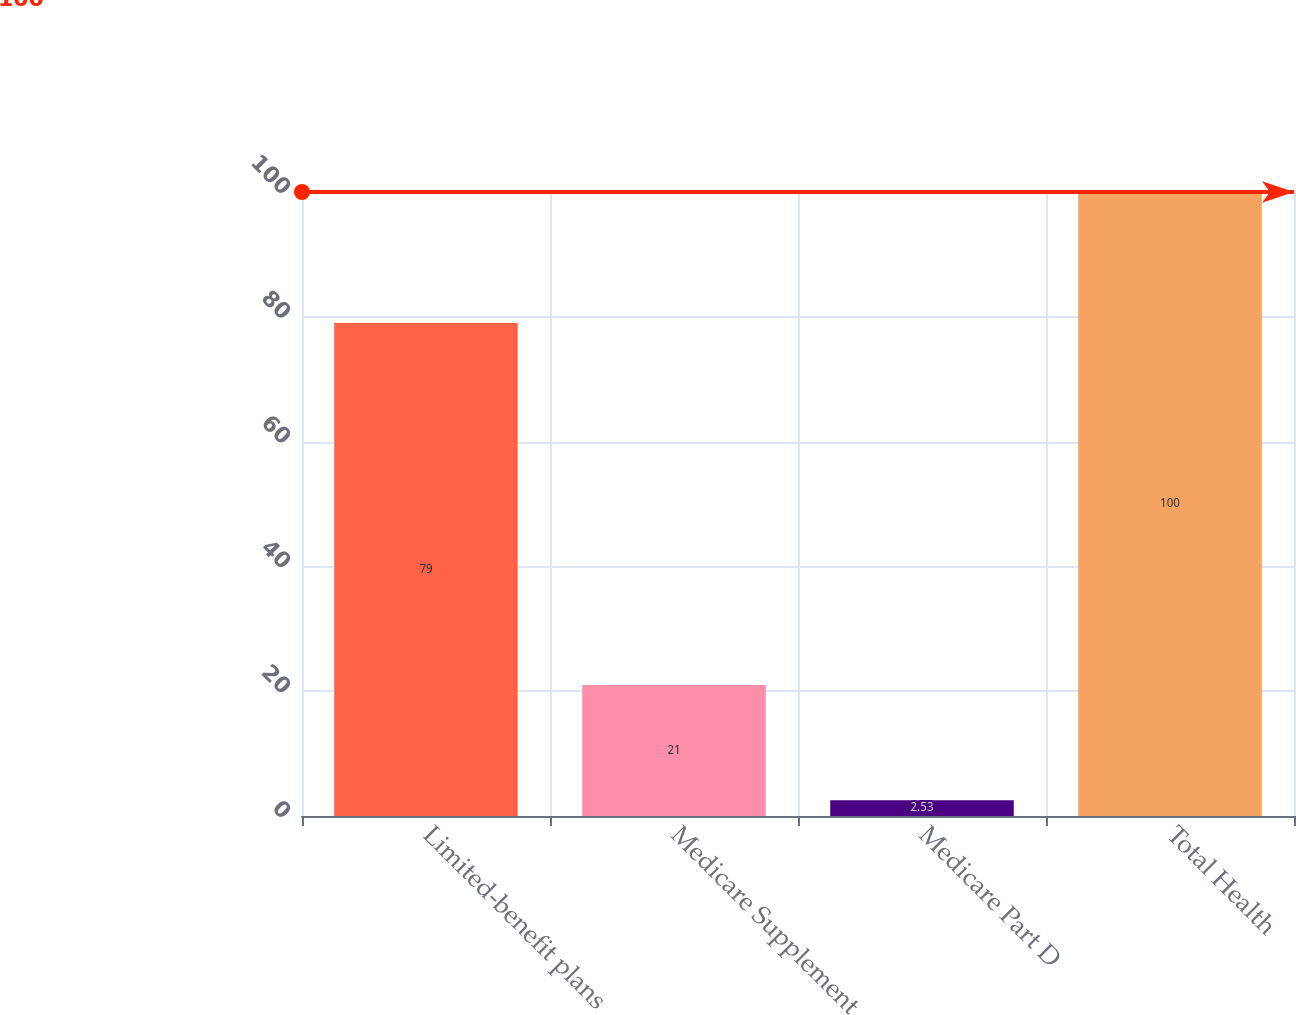Convert chart. <chart><loc_0><loc_0><loc_500><loc_500><bar_chart><fcel>Limited-benefit plans<fcel>Medicare Supplement<fcel>Medicare Part D<fcel>Total Health<nl><fcel>79<fcel>21<fcel>2.53<fcel>100<nl></chart> 